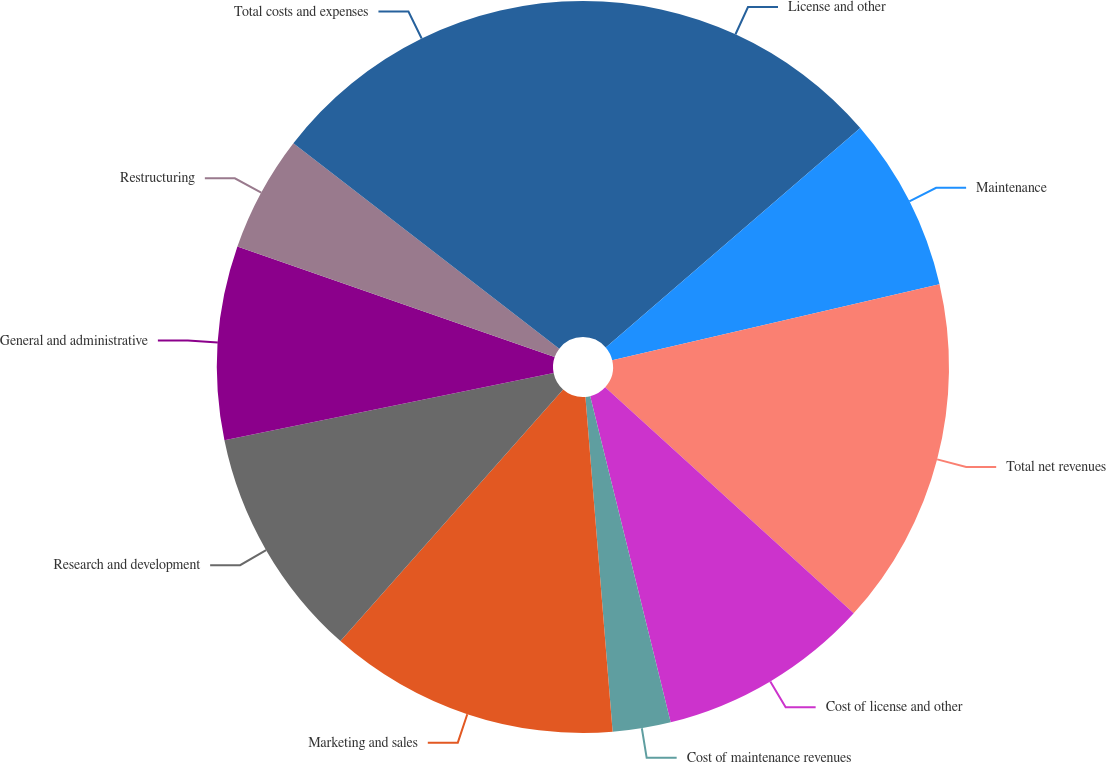Convert chart. <chart><loc_0><loc_0><loc_500><loc_500><pie_chart><fcel>License and other<fcel>Maintenance<fcel>Total net revenues<fcel>Cost of license and other<fcel>Cost of maintenance revenues<fcel>Marketing and sales<fcel>Research and development<fcel>General and administrative<fcel>Restructuring<fcel>Total costs and expenses<nl><fcel>13.68%<fcel>7.69%<fcel>15.38%<fcel>9.4%<fcel>2.56%<fcel>12.82%<fcel>10.26%<fcel>8.55%<fcel>5.13%<fcel>14.53%<nl></chart> 